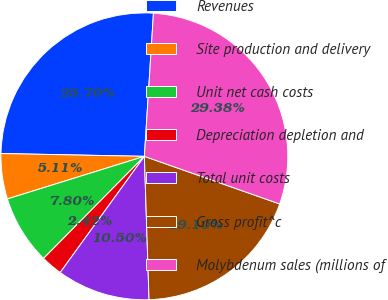Convert chart. <chart><loc_0><loc_0><loc_500><loc_500><pie_chart><fcel>Revenues<fcel>Site production and delivery<fcel>Unit net cash costs<fcel>Depreciation depletion and<fcel>Total unit costs<fcel>Gross profit^c<fcel>Molybdenum sales (millions of<nl><fcel>25.7%<fcel>5.11%<fcel>7.8%<fcel>2.42%<fcel>10.5%<fcel>19.1%<fcel>29.38%<nl></chart> 